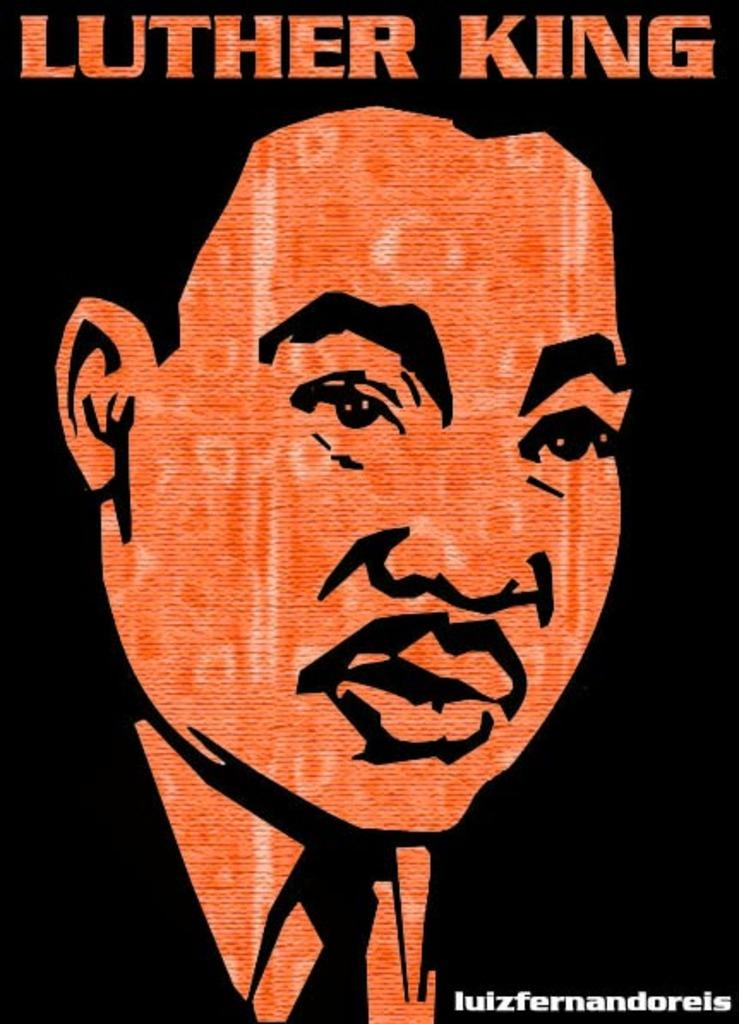What is the main subject of the poster in the image? The poster features a person. What else can be seen on the poster besides the person? There is writing on the poster. Can you tell me what type of bear is holding the lock in the image? There is no bear or lock present in the image; it only features a person and writing on a poster. 